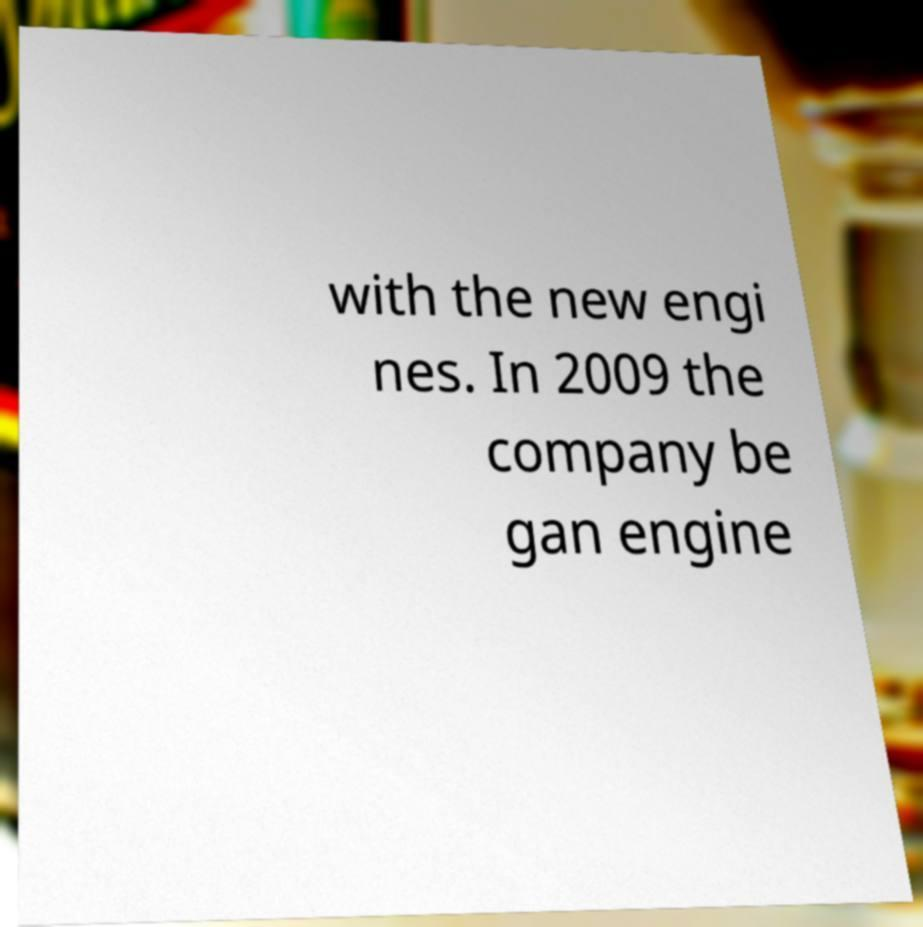Could you assist in decoding the text presented in this image and type it out clearly? with the new engi nes. In 2009 the company be gan engine 